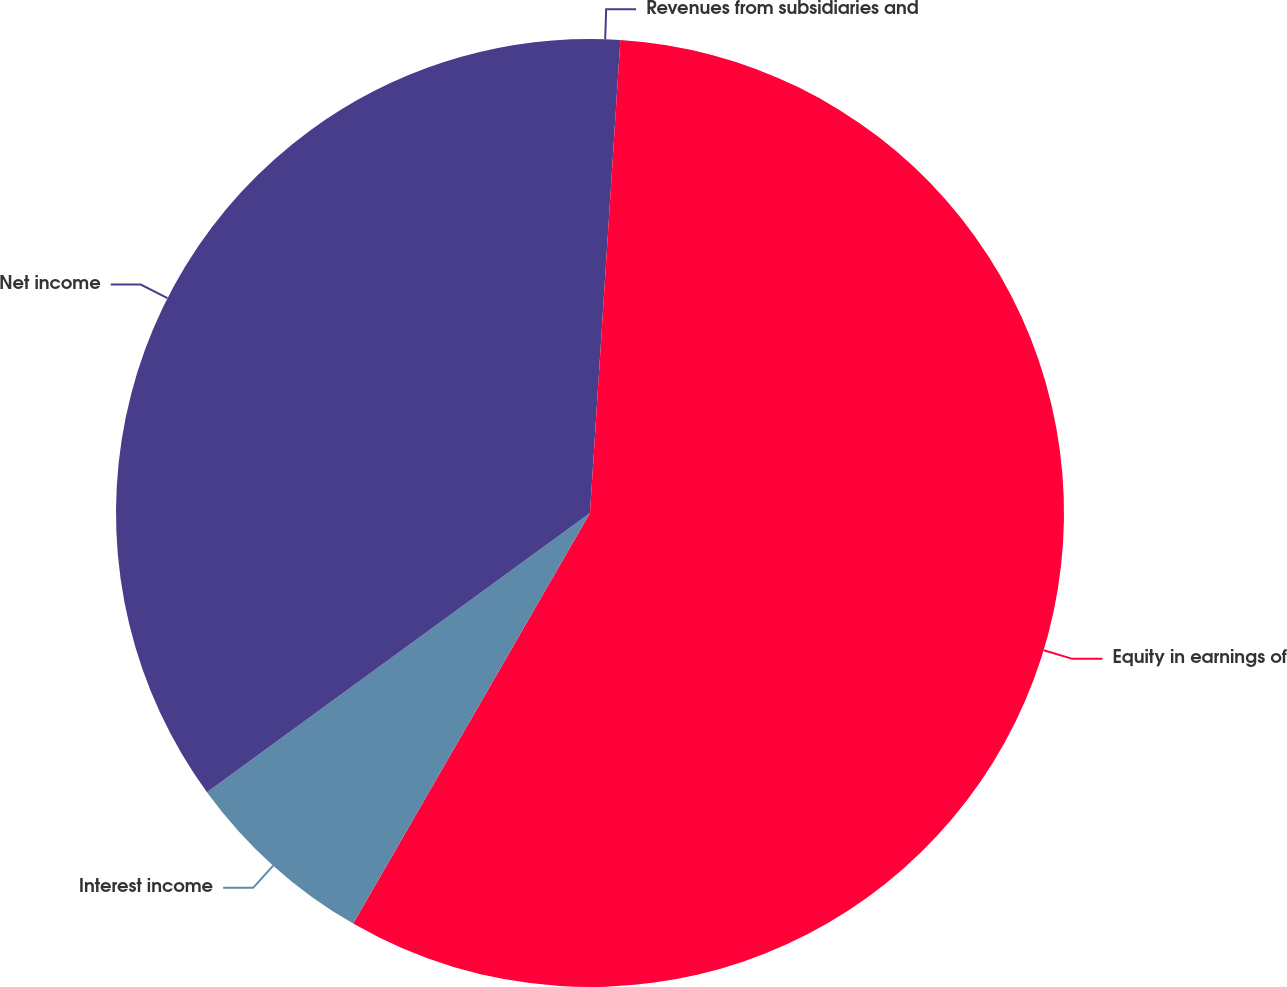<chart> <loc_0><loc_0><loc_500><loc_500><pie_chart><fcel>Revenues from subsidiaries and<fcel>Equity in earnings of<fcel>Interest income<fcel>Net income<nl><fcel>1.02%<fcel>57.3%<fcel>6.65%<fcel>35.02%<nl></chart> 